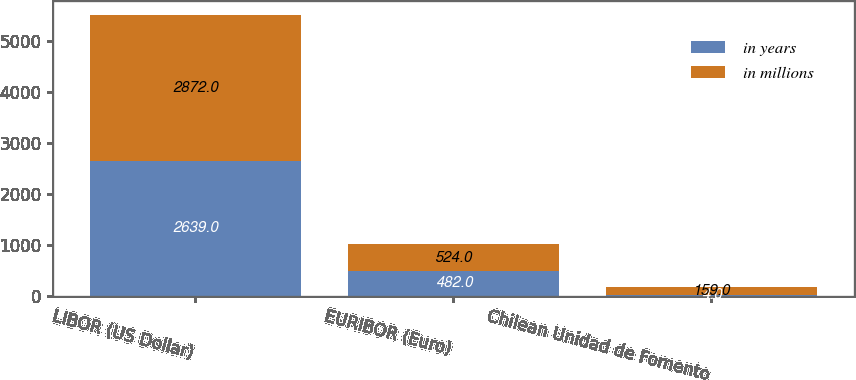Convert chart. <chart><loc_0><loc_0><loc_500><loc_500><stacked_bar_chart><ecel><fcel>LIBOR (US Dollar)<fcel>EURIBOR (Euro)<fcel>Chilean Unidad de Fomento<nl><fcel>in years<fcel>2639<fcel>482<fcel>4<nl><fcel>in millions<fcel>2872<fcel>524<fcel>159<nl></chart> 